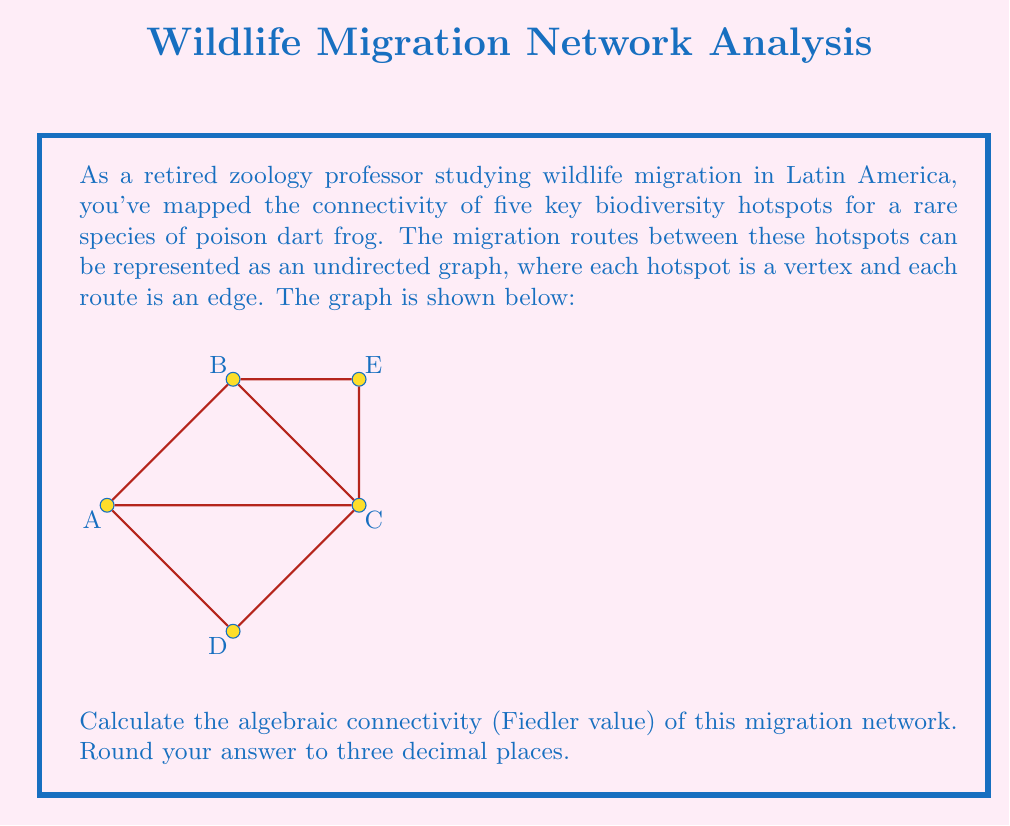Provide a solution to this math problem. To find the algebraic connectivity, we need to follow these steps:

1) First, construct the Laplacian matrix $L$ of the graph. For an undirected graph, $L = D - A$, where $D$ is the degree matrix and $A$ is the adjacency matrix.

2) The degree matrix $D$ is:
   $$D = \begin{bmatrix}
   3 & 0 & 0 & 0 & 0 \\
   0 & 3 & 0 & 0 & 0 \\
   0 & 0 & 4 & 0 & 0 \\
   0 & 0 & 0 & 2 & 0 \\
   0 & 0 & 0 & 0 & 2
   \end{bmatrix}$$

3) The adjacency matrix $A$ is:
   $$A = \begin{bmatrix}
   0 & 1 & 1 & 1 & 0 \\
   1 & 0 & 1 & 0 & 1 \\
   1 & 1 & 0 & 1 & 1 \\
   1 & 0 & 1 & 0 & 0 \\
   0 & 1 & 1 & 0 & 0
   \end{bmatrix}$$

4) Therefore, the Laplacian matrix $L = D - A$ is:
   $$L = \begin{bmatrix}
   3 & -1 & -1 & -1 & 0 \\
   -1 & 3 & -1 & 0 & -1 \\
   -1 & -1 & 4 & -1 & -1 \\
   -1 & 0 & -1 & 2 & 0 \\
   0 & -1 & -1 & 0 & 2
   \end{bmatrix}$$

5) The algebraic connectivity is the second smallest eigenvalue of $L$. We can find the eigenvalues using a computer algebra system or numerical methods.

6) The eigenvalues of $L$ are approximately:
   $0, 0.830, 2.382, 3.618, 5.170$

7) The second smallest eigenvalue (Fiedler value) is approximately 0.830.

8) Rounding to three decimal places, we get 0.830.
Answer: 0.830 